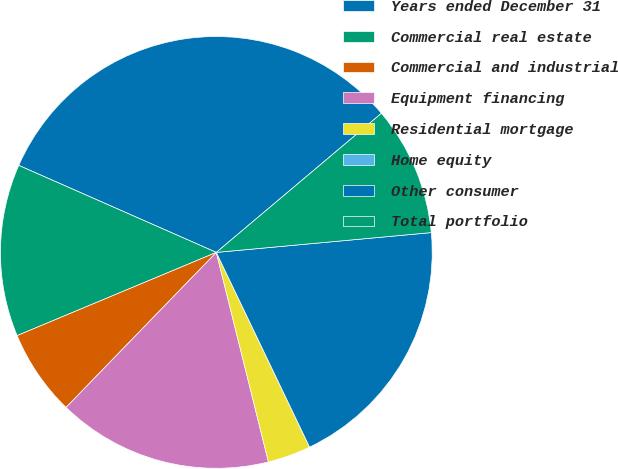Convert chart. <chart><loc_0><loc_0><loc_500><loc_500><pie_chart><fcel>Years ended December 31<fcel>Commercial real estate<fcel>Commercial and industrial<fcel>Equipment financing<fcel>Residential mortgage<fcel>Home equity<fcel>Other consumer<fcel>Total portfolio<nl><fcel>32.25%<fcel>12.9%<fcel>6.45%<fcel>16.13%<fcel>3.23%<fcel>0.0%<fcel>19.35%<fcel>9.68%<nl></chart> 